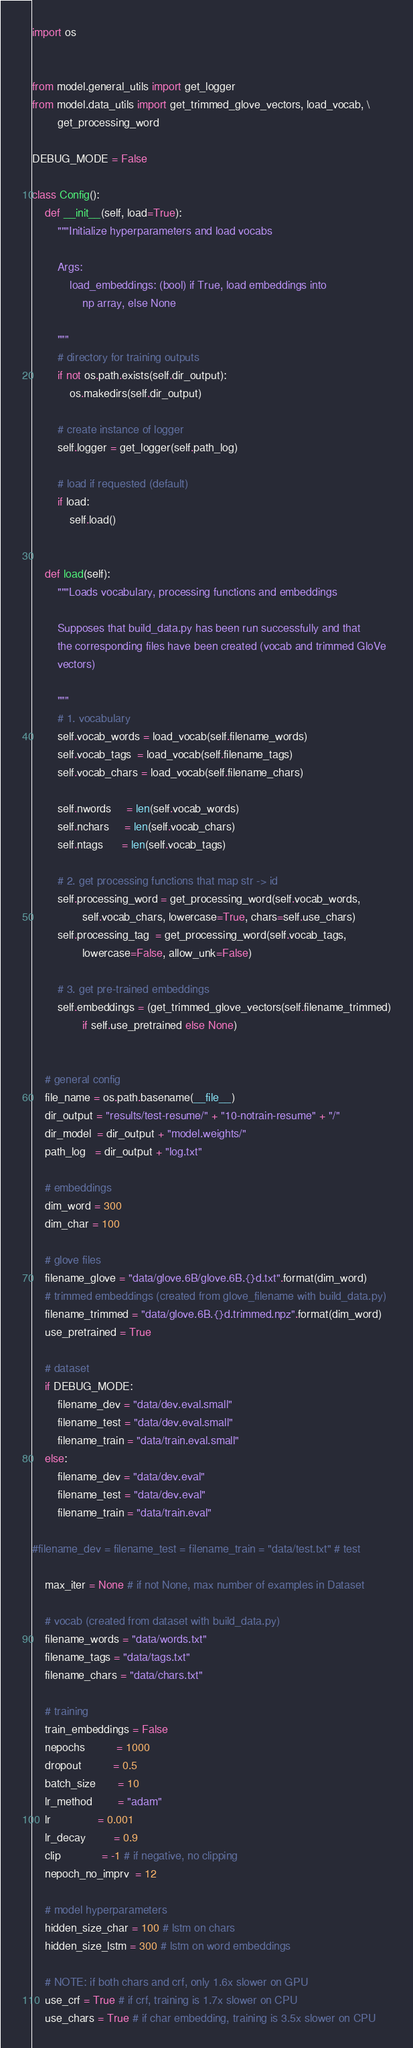Convert code to text. <code><loc_0><loc_0><loc_500><loc_500><_Python_>import os


from model.general_utils import get_logger
from model.data_utils import get_trimmed_glove_vectors, load_vocab, \
        get_processing_word

DEBUG_MODE = False

class Config():
    def __init__(self, load=True):
        """Initialize hyperparameters and load vocabs

        Args:
            load_embeddings: (bool) if True, load embeddings into
                np array, else None

        """
        # directory for training outputs
        if not os.path.exists(self.dir_output):
            os.makedirs(self.dir_output)

        # create instance of logger
        self.logger = get_logger(self.path_log)

        # load if requested (default)
        if load:
            self.load()


    def load(self):
        """Loads vocabulary, processing functions and embeddings

        Supposes that build_data.py has been run successfully and that
        the corresponding files have been created (vocab and trimmed GloVe
        vectors)

        """
        # 1. vocabulary
        self.vocab_words = load_vocab(self.filename_words)
        self.vocab_tags  = load_vocab(self.filename_tags)
        self.vocab_chars = load_vocab(self.filename_chars)

        self.nwords     = len(self.vocab_words)
        self.nchars     = len(self.vocab_chars)
        self.ntags      = len(self.vocab_tags)

        # 2. get processing functions that map str -> id
        self.processing_word = get_processing_word(self.vocab_words,
                self.vocab_chars, lowercase=True, chars=self.use_chars)
        self.processing_tag  = get_processing_word(self.vocab_tags,
                lowercase=False, allow_unk=False)

        # 3. get pre-trained embeddings
        self.embeddings = (get_trimmed_glove_vectors(self.filename_trimmed)
                if self.use_pretrained else None)


    # general config
    file_name = os.path.basename(__file__)
    dir_output = "results/test-resume/" + "10-notrain-resume" + "/"
    dir_model  = dir_output + "model.weights/"
    path_log   = dir_output + "log.txt"

    # embeddings
    dim_word = 300
    dim_char = 100

    # glove files
    filename_glove = "data/glove.6B/glove.6B.{}d.txt".format(dim_word)
    # trimmed embeddings (created from glove_filename with build_data.py)
    filename_trimmed = "data/glove.6B.{}d.trimmed.npz".format(dim_word)
    use_pretrained = True

    # dataset
    if DEBUG_MODE:
        filename_dev = "data/dev.eval.small"
        filename_test = "data/dev.eval.small"
        filename_train = "data/train.eval.small"
    else:
        filename_dev = "data/dev.eval"
        filename_test = "data/dev.eval"
        filename_train = "data/train.eval"

#filename_dev = filename_test = filename_train = "data/test.txt" # test

    max_iter = None # if not None, max number of examples in Dataset

    # vocab (created from dataset with build_data.py)
    filename_words = "data/words.txt"
    filename_tags = "data/tags.txt"
    filename_chars = "data/chars.txt"

    # training
    train_embeddings = False
    nepochs          = 1000
    dropout          = 0.5
    batch_size       = 10
    lr_method        = "adam"
    lr               = 0.001
    lr_decay         = 0.9
    clip             = -1 # if negative, no clipping
    nepoch_no_imprv  = 12

    # model hyperparameters
    hidden_size_char = 100 # lstm on chars
    hidden_size_lstm = 300 # lstm on word embeddings

    # NOTE: if both chars and crf, only 1.6x slower on GPU
    use_crf = True # if crf, training is 1.7x slower on CPU
    use_chars = True # if char embedding, training is 3.5x slower on CPU
</code> 